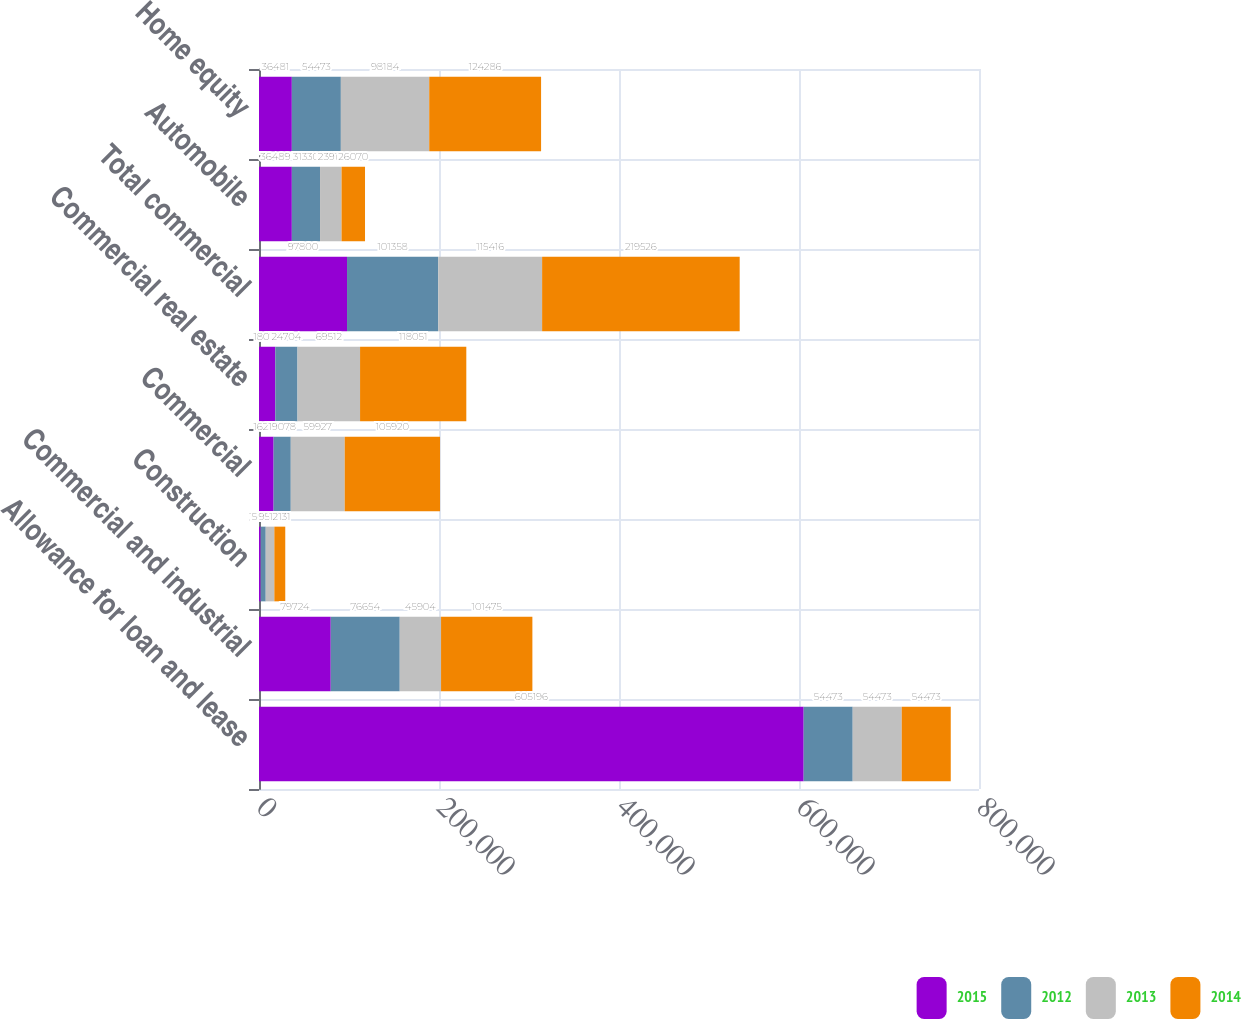<chart> <loc_0><loc_0><loc_500><loc_500><stacked_bar_chart><ecel><fcel>Allowance for loan and lease<fcel>Commercial and industrial<fcel>Construction<fcel>Commercial<fcel>Commercial real estate<fcel>Total commercial<fcel>Automobile<fcel>Home equity<nl><fcel>2015<fcel>605196<fcel>79724<fcel>1843<fcel>16233<fcel>18076<fcel>97800<fcel>36489<fcel>36481<nl><fcel>2012<fcel>54473<fcel>76654<fcel>5626<fcel>19078<fcel>24704<fcel>101358<fcel>31330<fcel>54473<nl><fcel>2013<fcel>54473<fcel>45904<fcel>9585<fcel>59927<fcel>69512<fcel>115416<fcel>23912<fcel>98184<nl><fcel>2014<fcel>54473<fcel>101475<fcel>12131<fcel>105920<fcel>118051<fcel>219526<fcel>26070<fcel>124286<nl></chart> 